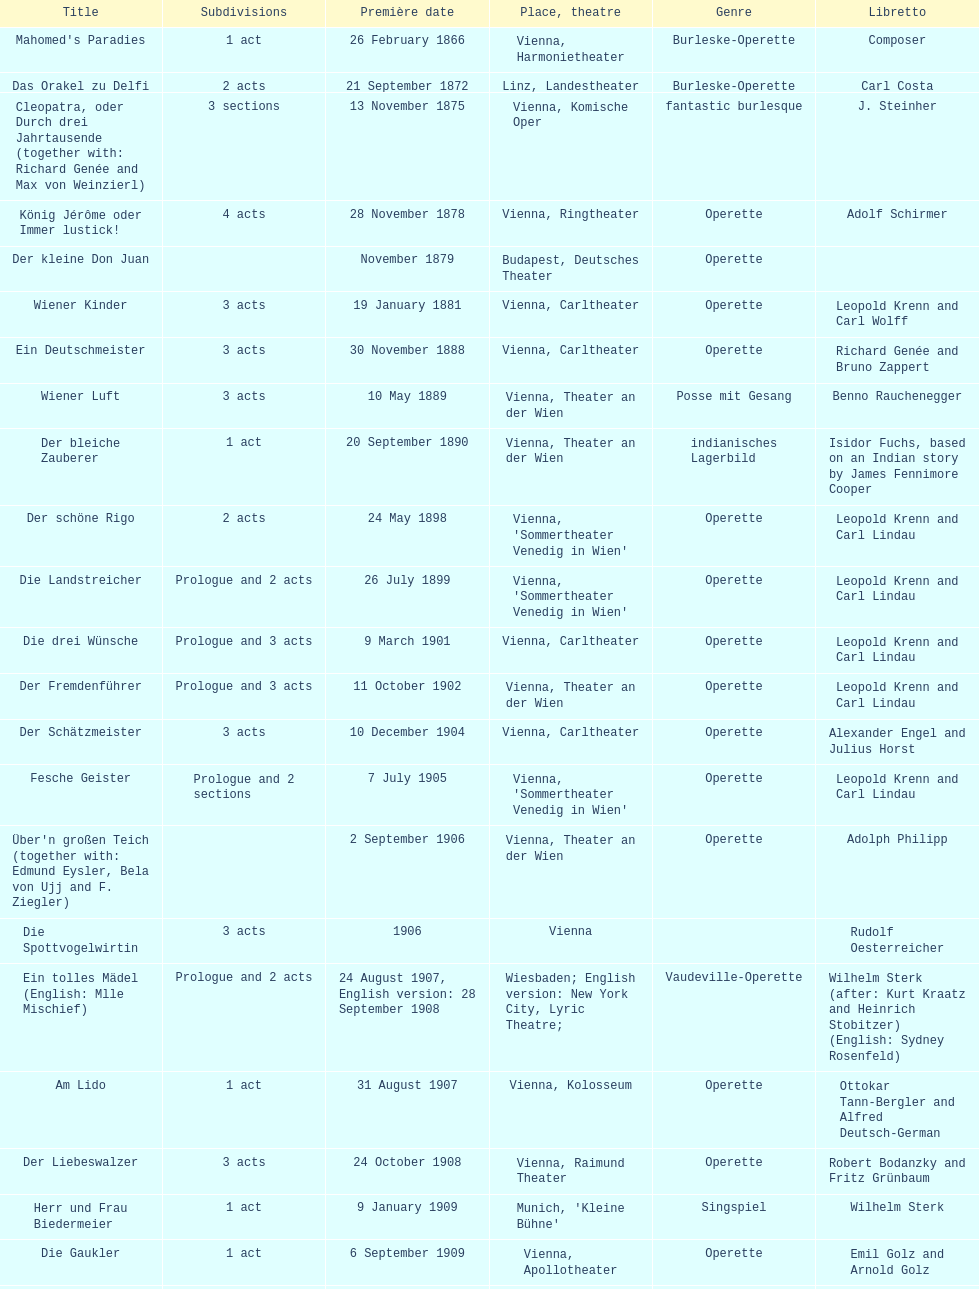How many number of 1 acts were there? 5. 